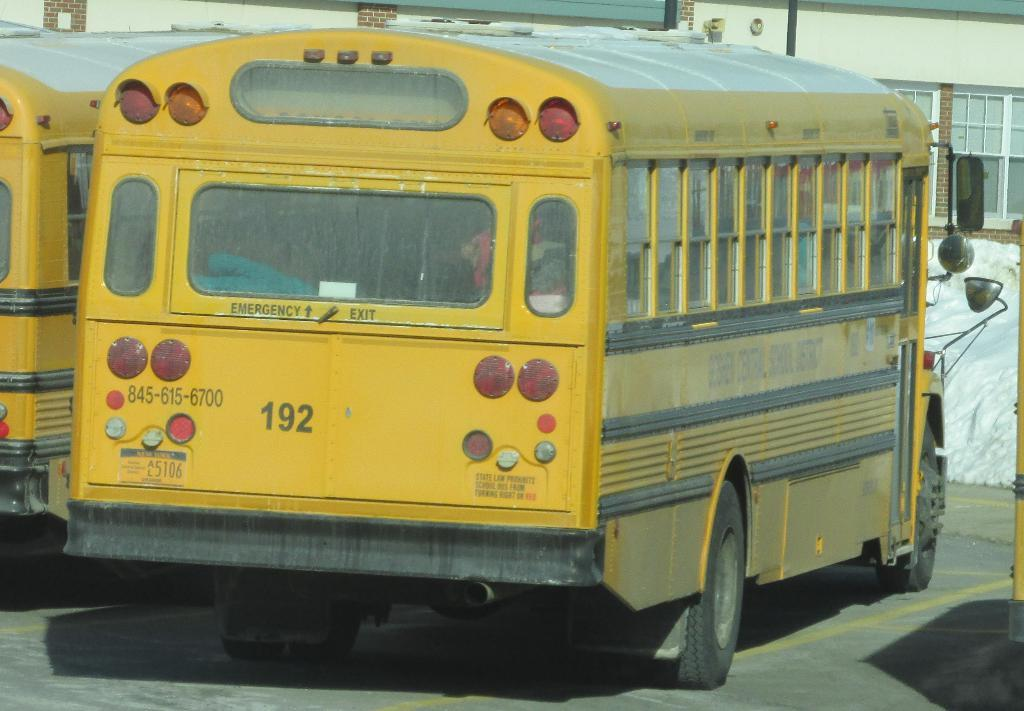<image>
Relay a brief, clear account of the picture shown. A yellow school bus sitting in a lot with other busses. 